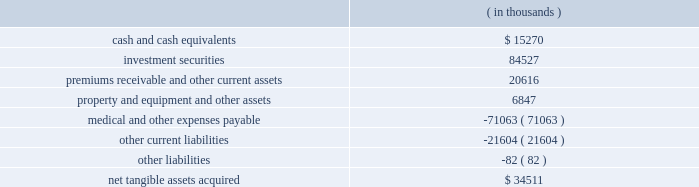Humana inc .
Notes to consolidated financial statements 2014 ( continued ) in any spe transactions .
The adoption of fin 46 or fin 46-r did not have a material impact on our financial position , results of operations , or cash flows .
In december 2004 , the fasb issued statement no .
123r , share-based payment , or statement 123r , which requires companies to expense the fair value of employee stock options and other forms of stock-based compensation .
This requirement represents a significant change because fixed-based stock option awards , a predominate form of stock compensation for us , were not recognized as compensation expense under apb 25 .
Statement 123r requires the cost of the award , as determined on the date of grant at fair value , be recognized over the period during which an employee is required to provide service in exchange for the award ( usually the vesting period ) .
The grant-date fair value of the award will be estimated using option-pricing models .
We are required to adopt statement 123r no later than july 1 , 2005 under one of three transition methods , including a prospective , retrospective and combination approach .
We previously disclosed on page 67 the effect of expensing stock options under a fair value approach using the black-scholes pricing model for 2004 , 2003 and 2002 .
We currently are evaluating all of the provisions of statement 123r and the expected effect on us including , among other items , reviewing compensation strategies related to stock-based awards , selecting an option pricing model and determining the transition method .
In march 2004 , the fasb issued eitf issue no .
03-1 , or eitf 03-1 , the meaning of other-than- temporary impairment and its application to certain investments .
Eitf 03-1 includes new guidance for evaluating and recording impairment losses on certain debt and equity investments when the fair value of the investment security is less than its carrying value .
In september 2004 , the fasb delayed the previously scheduled third quarter 2004 effective date until the issuance of additional implementation guidance , expected in 2005 .
Upon issuance of a final standard , we will evaluate the impact on our consolidated financial position and results of operations .
Acquisitions on february 16 , 2005 , we acquired careplus health plans of florida , or careplus , as well as its affiliated 10 medical centers and pharmacy company .
Careplus provides medicare advantage hmo plans and benefits to medicare eligible members in miami-dade , broward and palm beach counties .
This acquisition enhances our medicare market position in south florida .
We paid approximately $ 450 million in cash including estimated transaction costs , subject to a balance sheet settlement process with a nine month claims run-out period .
We currently are in the process of allocating the purchase price to the net tangible and intangible assets .
On april 1 , 2004 , we acquired ochsner health plan , or ochsner , from the ochsner clinic foundation .
Ochsner is a louisiana health benefits company offering network-based managed care plans to employer-groups and medicare eligible members .
This acquisition enabled us to enter a new market with significant market share which should facilitate new sales opportunities in this and surrounding markets , including houston , texas .
We paid $ 157.1 million in cash , including transaction costs .
The fair value of the tangible assets ( liabilities ) as of the acquisition date are as follows: .

What is the percentage of other current liabilities among the total liabilities? 
Rationale: it is the value of other current liabilities divided by the total liabilities .
Computations: (21604 / (82 + (71063 + 21604)))
Answer: 0.23293. 